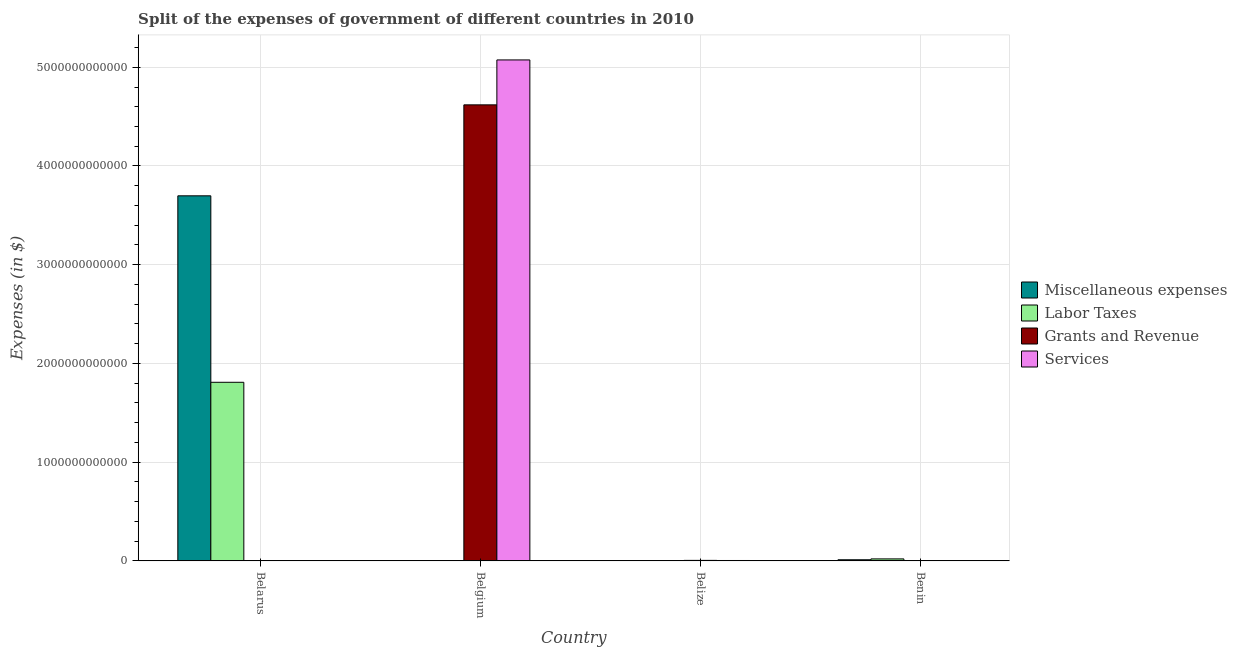How many groups of bars are there?
Provide a succinct answer. 4. How many bars are there on the 3rd tick from the right?
Ensure brevity in your answer.  4. What is the label of the 1st group of bars from the left?
Provide a succinct answer. Belarus. What is the amount spent on miscellaneous expenses in Belgium?
Provide a succinct answer. 3.68e+09. Across all countries, what is the maximum amount spent on miscellaneous expenses?
Ensure brevity in your answer.  3.70e+12. Across all countries, what is the minimum amount spent on grants and revenue?
Your answer should be compact. 1.19e+08. In which country was the amount spent on labor taxes maximum?
Offer a terse response. Belarus. In which country was the amount spent on grants and revenue minimum?
Make the answer very short. Benin. What is the total amount spent on miscellaneous expenses in the graph?
Offer a terse response. 3.71e+12. What is the difference between the amount spent on miscellaneous expenses in Belarus and that in Belize?
Offer a terse response. 3.70e+12. What is the difference between the amount spent on miscellaneous expenses in Belarus and the amount spent on services in Belgium?
Ensure brevity in your answer.  -1.38e+12. What is the average amount spent on miscellaneous expenses per country?
Keep it short and to the point. 9.28e+11. What is the difference between the amount spent on miscellaneous expenses and amount spent on labor taxes in Belgium?
Make the answer very short. 2.55e+09. What is the ratio of the amount spent on services in Belgium to that in Belize?
Your answer should be compact. 1247.41. Is the amount spent on grants and revenue in Belarus less than that in Belgium?
Your answer should be very brief. Yes. What is the difference between the highest and the second highest amount spent on services?
Provide a succinct answer. 5.07e+12. What is the difference between the highest and the lowest amount spent on grants and revenue?
Offer a very short reply. 4.62e+12. In how many countries, is the amount spent on grants and revenue greater than the average amount spent on grants and revenue taken over all countries?
Keep it short and to the point. 1. What does the 1st bar from the left in Belize represents?
Your response must be concise. Miscellaneous expenses. What does the 4th bar from the right in Belize represents?
Give a very brief answer. Miscellaneous expenses. Is it the case that in every country, the sum of the amount spent on miscellaneous expenses and amount spent on labor taxes is greater than the amount spent on grants and revenue?
Offer a very short reply. No. What is the difference between two consecutive major ticks on the Y-axis?
Provide a succinct answer. 1.00e+12. Are the values on the major ticks of Y-axis written in scientific E-notation?
Make the answer very short. No. Does the graph contain any zero values?
Make the answer very short. No. Does the graph contain grids?
Offer a terse response. Yes. What is the title of the graph?
Make the answer very short. Split of the expenses of government of different countries in 2010. What is the label or title of the X-axis?
Offer a very short reply. Country. What is the label or title of the Y-axis?
Your answer should be very brief. Expenses (in $). What is the Expenses (in $) in Miscellaneous expenses in Belarus?
Your answer should be compact. 3.70e+12. What is the Expenses (in $) in Labor Taxes in Belarus?
Offer a terse response. 1.81e+12. What is the Expenses (in $) in Grants and Revenue in Belarus?
Provide a succinct answer. 1.71e+08. What is the Expenses (in $) in Services in Belarus?
Keep it short and to the point. 4.35e+08. What is the Expenses (in $) in Miscellaneous expenses in Belgium?
Make the answer very short. 3.68e+09. What is the Expenses (in $) in Labor Taxes in Belgium?
Offer a very short reply. 1.13e+09. What is the Expenses (in $) in Grants and Revenue in Belgium?
Provide a succinct answer. 4.62e+12. What is the Expenses (in $) in Services in Belgium?
Make the answer very short. 5.07e+12. What is the Expenses (in $) in Miscellaneous expenses in Belize?
Make the answer very short. 1.66e+07. What is the Expenses (in $) of Labor Taxes in Belize?
Give a very brief answer. 6.57e+06. What is the Expenses (in $) in Grants and Revenue in Belize?
Offer a very short reply. 5.17e+09. What is the Expenses (in $) of Services in Belize?
Your response must be concise. 4.07e+09. What is the Expenses (in $) of Miscellaneous expenses in Benin?
Provide a short and direct response. 1.14e+1. What is the Expenses (in $) in Labor Taxes in Benin?
Your response must be concise. 2.03e+1. What is the Expenses (in $) in Grants and Revenue in Benin?
Offer a very short reply. 1.19e+08. What is the Expenses (in $) of Services in Benin?
Your answer should be compact. 1.65e+08. Across all countries, what is the maximum Expenses (in $) in Miscellaneous expenses?
Offer a very short reply. 3.70e+12. Across all countries, what is the maximum Expenses (in $) of Labor Taxes?
Your answer should be very brief. 1.81e+12. Across all countries, what is the maximum Expenses (in $) of Grants and Revenue?
Provide a short and direct response. 4.62e+12. Across all countries, what is the maximum Expenses (in $) in Services?
Offer a very short reply. 5.07e+12. Across all countries, what is the minimum Expenses (in $) in Miscellaneous expenses?
Your answer should be compact. 1.66e+07. Across all countries, what is the minimum Expenses (in $) of Labor Taxes?
Give a very brief answer. 6.57e+06. Across all countries, what is the minimum Expenses (in $) in Grants and Revenue?
Offer a terse response. 1.19e+08. Across all countries, what is the minimum Expenses (in $) of Services?
Keep it short and to the point. 1.65e+08. What is the total Expenses (in $) of Miscellaneous expenses in the graph?
Your response must be concise. 3.71e+12. What is the total Expenses (in $) in Labor Taxes in the graph?
Your answer should be compact. 1.83e+12. What is the total Expenses (in $) of Grants and Revenue in the graph?
Your answer should be compact. 4.62e+12. What is the total Expenses (in $) of Services in the graph?
Your answer should be very brief. 5.08e+12. What is the difference between the Expenses (in $) of Miscellaneous expenses in Belarus and that in Belgium?
Offer a very short reply. 3.69e+12. What is the difference between the Expenses (in $) of Labor Taxes in Belarus and that in Belgium?
Your answer should be very brief. 1.81e+12. What is the difference between the Expenses (in $) of Grants and Revenue in Belarus and that in Belgium?
Make the answer very short. -4.62e+12. What is the difference between the Expenses (in $) of Services in Belarus and that in Belgium?
Offer a very short reply. -5.07e+12. What is the difference between the Expenses (in $) in Miscellaneous expenses in Belarus and that in Belize?
Offer a terse response. 3.70e+12. What is the difference between the Expenses (in $) in Labor Taxes in Belarus and that in Belize?
Provide a succinct answer. 1.81e+12. What is the difference between the Expenses (in $) in Grants and Revenue in Belarus and that in Belize?
Ensure brevity in your answer.  -5.00e+09. What is the difference between the Expenses (in $) of Services in Belarus and that in Belize?
Your response must be concise. -3.63e+09. What is the difference between the Expenses (in $) of Miscellaneous expenses in Belarus and that in Benin?
Your response must be concise. 3.69e+12. What is the difference between the Expenses (in $) in Labor Taxes in Belarus and that in Benin?
Provide a succinct answer. 1.79e+12. What is the difference between the Expenses (in $) of Grants and Revenue in Belarus and that in Benin?
Provide a short and direct response. 5.17e+07. What is the difference between the Expenses (in $) in Services in Belarus and that in Benin?
Ensure brevity in your answer.  2.70e+08. What is the difference between the Expenses (in $) of Miscellaneous expenses in Belgium and that in Belize?
Keep it short and to the point. 3.67e+09. What is the difference between the Expenses (in $) of Labor Taxes in Belgium and that in Belize?
Your response must be concise. 1.12e+09. What is the difference between the Expenses (in $) in Grants and Revenue in Belgium and that in Belize?
Your answer should be compact. 4.61e+12. What is the difference between the Expenses (in $) of Services in Belgium and that in Belize?
Your answer should be very brief. 5.07e+12. What is the difference between the Expenses (in $) of Miscellaneous expenses in Belgium and that in Benin?
Your response must be concise. -7.70e+09. What is the difference between the Expenses (in $) of Labor Taxes in Belgium and that in Benin?
Offer a very short reply. -1.92e+1. What is the difference between the Expenses (in $) of Grants and Revenue in Belgium and that in Benin?
Offer a terse response. 4.62e+12. What is the difference between the Expenses (in $) of Services in Belgium and that in Benin?
Your response must be concise. 5.07e+12. What is the difference between the Expenses (in $) of Miscellaneous expenses in Belize and that in Benin?
Give a very brief answer. -1.14e+1. What is the difference between the Expenses (in $) in Labor Taxes in Belize and that in Benin?
Make the answer very short. -2.03e+1. What is the difference between the Expenses (in $) of Grants and Revenue in Belize and that in Benin?
Provide a succinct answer. 5.05e+09. What is the difference between the Expenses (in $) of Services in Belize and that in Benin?
Offer a terse response. 3.90e+09. What is the difference between the Expenses (in $) in Miscellaneous expenses in Belarus and the Expenses (in $) in Labor Taxes in Belgium?
Your response must be concise. 3.70e+12. What is the difference between the Expenses (in $) of Miscellaneous expenses in Belarus and the Expenses (in $) of Grants and Revenue in Belgium?
Your answer should be compact. -9.21e+11. What is the difference between the Expenses (in $) of Miscellaneous expenses in Belarus and the Expenses (in $) of Services in Belgium?
Your response must be concise. -1.38e+12. What is the difference between the Expenses (in $) in Labor Taxes in Belarus and the Expenses (in $) in Grants and Revenue in Belgium?
Make the answer very short. -2.81e+12. What is the difference between the Expenses (in $) of Labor Taxes in Belarus and the Expenses (in $) of Services in Belgium?
Your answer should be very brief. -3.27e+12. What is the difference between the Expenses (in $) in Grants and Revenue in Belarus and the Expenses (in $) in Services in Belgium?
Your response must be concise. -5.07e+12. What is the difference between the Expenses (in $) of Miscellaneous expenses in Belarus and the Expenses (in $) of Labor Taxes in Belize?
Your answer should be compact. 3.70e+12. What is the difference between the Expenses (in $) in Miscellaneous expenses in Belarus and the Expenses (in $) in Grants and Revenue in Belize?
Make the answer very short. 3.69e+12. What is the difference between the Expenses (in $) in Miscellaneous expenses in Belarus and the Expenses (in $) in Services in Belize?
Your response must be concise. 3.69e+12. What is the difference between the Expenses (in $) in Labor Taxes in Belarus and the Expenses (in $) in Grants and Revenue in Belize?
Offer a terse response. 1.80e+12. What is the difference between the Expenses (in $) of Labor Taxes in Belarus and the Expenses (in $) of Services in Belize?
Keep it short and to the point. 1.81e+12. What is the difference between the Expenses (in $) in Grants and Revenue in Belarus and the Expenses (in $) in Services in Belize?
Offer a terse response. -3.90e+09. What is the difference between the Expenses (in $) of Miscellaneous expenses in Belarus and the Expenses (in $) of Labor Taxes in Benin?
Your answer should be very brief. 3.68e+12. What is the difference between the Expenses (in $) of Miscellaneous expenses in Belarus and the Expenses (in $) of Grants and Revenue in Benin?
Offer a terse response. 3.70e+12. What is the difference between the Expenses (in $) in Miscellaneous expenses in Belarus and the Expenses (in $) in Services in Benin?
Provide a short and direct response. 3.70e+12. What is the difference between the Expenses (in $) in Labor Taxes in Belarus and the Expenses (in $) in Grants and Revenue in Benin?
Make the answer very short. 1.81e+12. What is the difference between the Expenses (in $) in Labor Taxes in Belarus and the Expenses (in $) in Services in Benin?
Keep it short and to the point. 1.81e+12. What is the difference between the Expenses (in $) of Grants and Revenue in Belarus and the Expenses (in $) of Services in Benin?
Your answer should be very brief. 5.79e+06. What is the difference between the Expenses (in $) of Miscellaneous expenses in Belgium and the Expenses (in $) of Labor Taxes in Belize?
Offer a very short reply. 3.68e+09. What is the difference between the Expenses (in $) in Miscellaneous expenses in Belgium and the Expenses (in $) in Grants and Revenue in Belize?
Offer a terse response. -1.48e+09. What is the difference between the Expenses (in $) of Miscellaneous expenses in Belgium and the Expenses (in $) of Services in Belize?
Keep it short and to the point. -3.85e+08. What is the difference between the Expenses (in $) of Labor Taxes in Belgium and the Expenses (in $) of Grants and Revenue in Belize?
Give a very brief answer. -4.04e+09. What is the difference between the Expenses (in $) of Labor Taxes in Belgium and the Expenses (in $) of Services in Belize?
Offer a terse response. -2.94e+09. What is the difference between the Expenses (in $) of Grants and Revenue in Belgium and the Expenses (in $) of Services in Belize?
Make the answer very short. 4.62e+12. What is the difference between the Expenses (in $) in Miscellaneous expenses in Belgium and the Expenses (in $) in Labor Taxes in Benin?
Offer a very short reply. -1.66e+1. What is the difference between the Expenses (in $) in Miscellaneous expenses in Belgium and the Expenses (in $) in Grants and Revenue in Benin?
Make the answer very short. 3.56e+09. What is the difference between the Expenses (in $) in Miscellaneous expenses in Belgium and the Expenses (in $) in Services in Benin?
Make the answer very short. 3.52e+09. What is the difference between the Expenses (in $) in Labor Taxes in Belgium and the Expenses (in $) in Grants and Revenue in Benin?
Your answer should be very brief. 1.01e+09. What is the difference between the Expenses (in $) in Labor Taxes in Belgium and the Expenses (in $) in Services in Benin?
Make the answer very short. 9.64e+08. What is the difference between the Expenses (in $) in Grants and Revenue in Belgium and the Expenses (in $) in Services in Benin?
Your answer should be very brief. 4.62e+12. What is the difference between the Expenses (in $) in Miscellaneous expenses in Belize and the Expenses (in $) in Labor Taxes in Benin?
Keep it short and to the point. -2.03e+1. What is the difference between the Expenses (in $) of Miscellaneous expenses in Belize and the Expenses (in $) of Grants and Revenue in Benin?
Offer a very short reply. -1.02e+08. What is the difference between the Expenses (in $) in Miscellaneous expenses in Belize and the Expenses (in $) in Services in Benin?
Provide a short and direct response. -1.48e+08. What is the difference between the Expenses (in $) in Labor Taxes in Belize and the Expenses (in $) in Grants and Revenue in Benin?
Make the answer very short. -1.12e+08. What is the difference between the Expenses (in $) of Labor Taxes in Belize and the Expenses (in $) of Services in Benin?
Offer a very short reply. -1.58e+08. What is the difference between the Expenses (in $) of Grants and Revenue in Belize and the Expenses (in $) of Services in Benin?
Ensure brevity in your answer.  5.00e+09. What is the average Expenses (in $) of Miscellaneous expenses per country?
Ensure brevity in your answer.  9.28e+11. What is the average Expenses (in $) in Labor Taxes per country?
Your answer should be compact. 4.58e+11. What is the average Expenses (in $) in Grants and Revenue per country?
Make the answer very short. 1.16e+12. What is the average Expenses (in $) in Services per country?
Offer a terse response. 1.27e+12. What is the difference between the Expenses (in $) of Miscellaneous expenses and Expenses (in $) of Labor Taxes in Belarus?
Offer a terse response. 1.89e+12. What is the difference between the Expenses (in $) of Miscellaneous expenses and Expenses (in $) of Grants and Revenue in Belarus?
Your answer should be very brief. 3.70e+12. What is the difference between the Expenses (in $) of Miscellaneous expenses and Expenses (in $) of Services in Belarus?
Provide a succinct answer. 3.70e+12. What is the difference between the Expenses (in $) in Labor Taxes and Expenses (in $) in Grants and Revenue in Belarus?
Offer a terse response. 1.81e+12. What is the difference between the Expenses (in $) in Labor Taxes and Expenses (in $) in Services in Belarus?
Provide a succinct answer. 1.81e+12. What is the difference between the Expenses (in $) in Grants and Revenue and Expenses (in $) in Services in Belarus?
Your response must be concise. -2.65e+08. What is the difference between the Expenses (in $) in Miscellaneous expenses and Expenses (in $) in Labor Taxes in Belgium?
Provide a short and direct response. 2.55e+09. What is the difference between the Expenses (in $) of Miscellaneous expenses and Expenses (in $) of Grants and Revenue in Belgium?
Your response must be concise. -4.62e+12. What is the difference between the Expenses (in $) of Miscellaneous expenses and Expenses (in $) of Services in Belgium?
Your answer should be very brief. -5.07e+12. What is the difference between the Expenses (in $) in Labor Taxes and Expenses (in $) in Grants and Revenue in Belgium?
Your response must be concise. -4.62e+12. What is the difference between the Expenses (in $) of Labor Taxes and Expenses (in $) of Services in Belgium?
Your response must be concise. -5.07e+12. What is the difference between the Expenses (in $) of Grants and Revenue and Expenses (in $) of Services in Belgium?
Your answer should be very brief. -4.55e+11. What is the difference between the Expenses (in $) in Miscellaneous expenses and Expenses (in $) in Labor Taxes in Belize?
Provide a succinct answer. 9.98e+06. What is the difference between the Expenses (in $) of Miscellaneous expenses and Expenses (in $) of Grants and Revenue in Belize?
Provide a short and direct response. -5.15e+09. What is the difference between the Expenses (in $) of Miscellaneous expenses and Expenses (in $) of Services in Belize?
Offer a terse response. -4.05e+09. What is the difference between the Expenses (in $) in Labor Taxes and Expenses (in $) in Grants and Revenue in Belize?
Make the answer very short. -5.16e+09. What is the difference between the Expenses (in $) in Labor Taxes and Expenses (in $) in Services in Belize?
Your answer should be very brief. -4.06e+09. What is the difference between the Expenses (in $) in Grants and Revenue and Expenses (in $) in Services in Belize?
Offer a very short reply. 1.10e+09. What is the difference between the Expenses (in $) in Miscellaneous expenses and Expenses (in $) in Labor Taxes in Benin?
Offer a terse response. -8.90e+09. What is the difference between the Expenses (in $) in Miscellaneous expenses and Expenses (in $) in Grants and Revenue in Benin?
Give a very brief answer. 1.13e+1. What is the difference between the Expenses (in $) of Miscellaneous expenses and Expenses (in $) of Services in Benin?
Your response must be concise. 1.12e+1. What is the difference between the Expenses (in $) of Labor Taxes and Expenses (in $) of Grants and Revenue in Benin?
Ensure brevity in your answer.  2.02e+1. What is the difference between the Expenses (in $) in Labor Taxes and Expenses (in $) in Services in Benin?
Offer a terse response. 2.01e+1. What is the difference between the Expenses (in $) of Grants and Revenue and Expenses (in $) of Services in Benin?
Provide a succinct answer. -4.59e+07. What is the ratio of the Expenses (in $) of Miscellaneous expenses in Belarus to that in Belgium?
Offer a very short reply. 1004.07. What is the ratio of the Expenses (in $) in Labor Taxes in Belarus to that in Belgium?
Provide a succinct answer. 1602.26. What is the ratio of the Expenses (in $) in Grants and Revenue in Belarus to that in Belgium?
Offer a terse response. 0. What is the ratio of the Expenses (in $) of Services in Belarus to that in Belgium?
Give a very brief answer. 0. What is the ratio of the Expenses (in $) in Miscellaneous expenses in Belarus to that in Belize?
Offer a terse response. 2.23e+05. What is the ratio of the Expenses (in $) in Labor Taxes in Belarus to that in Belize?
Your answer should be compact. 2.75e+05. What is the ratio of the Expenses (in $) of Grants and Revenue in Belarus to that in Belize?
Ensure brevity in your answer.  0.03. What is the ratio of the Expenses (in $) in Services in Belarus to that in Belize?
Your response must be concise. 0.11. What is the ratio of the Expenses (in $) in Miscellaneous expenses in Belarus to that in Benin?
Provide a succinct answer. 324.83. What is the ratio of the Expenses (in $) in Labor Taxes in Belarus to that in Benin?
Offer a terse response. 89.2. What is the ratio of the Expenses (in $) in Grants and Revenue in Belarus to that in Benin?
Keep it short and to the point. 1.43. What is the ratio of the Expenses (in $) of Services in Belarus to that in Benin?
Provide a short and direct response. 2.64. What is the ratio of the Expenses (in $) in Miscellaneous expenses in Belgium to that in Belize?
Keep it short and to the point. 222.46. What is the ratio of the Expenses (in $) in Labor Taxes in Belgium to that in Belize?
Offer a very short reply. 171.86. What is the ratio of the Expenses (in $) of Grants and Revenue in Belgium to that in Belize?
Provide a succinct answer. 894.14. What is the ratio of the Expenses (in $) of Services in Belgium to that in Belize?
Provide a succinct answer. 1247.41. What is the ratio of the Expenses (in $) in Miscellaneous expenses in Belgium to that in Benin?
Your response must be concise. 0.32. What is the ratio of the Expenses (in $) of Labor Taxes in Belgium to that in Benin?
Provide a short and direct response. 0.06. What is the ratio of the Expenses (in $) of Grants and Revenue in Belgium to that in Benin?
Keep it short and to the point. 3.88e+04. What is the ratio of the Expenses (in $) in Services in Belgium to that in Benin?
Provide a short and direct response. 3.08e+04. What is the ratio of the Expenses (in $) in Miscellaneous expenses in Belize to that in Benin?
Offer a terse response. 0. What is the ratio of the Expenses (in $) of Grants and Revenue in Belize to that in Benin?
Offer a terse response. 43.44. What is the ratio of the Expenses (in $) in Services in Belize to that in Benin?
Keep it short and to the point. 24.68. What is the difference between the highest and the second highest Expenses (in $) in Miscellaneous expenses?
Provide a succinct answer. 3.69e+12. What is the difference between the highest and the second highest Expenses (in $) of Labor Taxes?
Make the answer very short. 1.79e+12. What is the difference between the highest and the second highest Expenses (in $) of Grants and Revenue?
Ensure brevity in your answer.  4.61e+12. What is the difference between the highest and the second highest Expenses (in $) in Services?
Offer a terse response. 5.07e+12. What is the difference between the highest and the lowest Expenses (in $) in Miscellaneous expenses?
Keep it short and to the point. 3.70e+12. What is the difference between the highest and the lowest Expenses (in $) of Labor Taxes?
Keep it short and to the point. 1.81e+12. What is the difference between the highest and the lowest Expenses (in $) in Grants and Revenue?
Keep it short and to the point. 4.62e+12. What is the difference between the highest and the lowest Expenses (in $) in Services?
Give a very brief answer. 5.07e+12. 